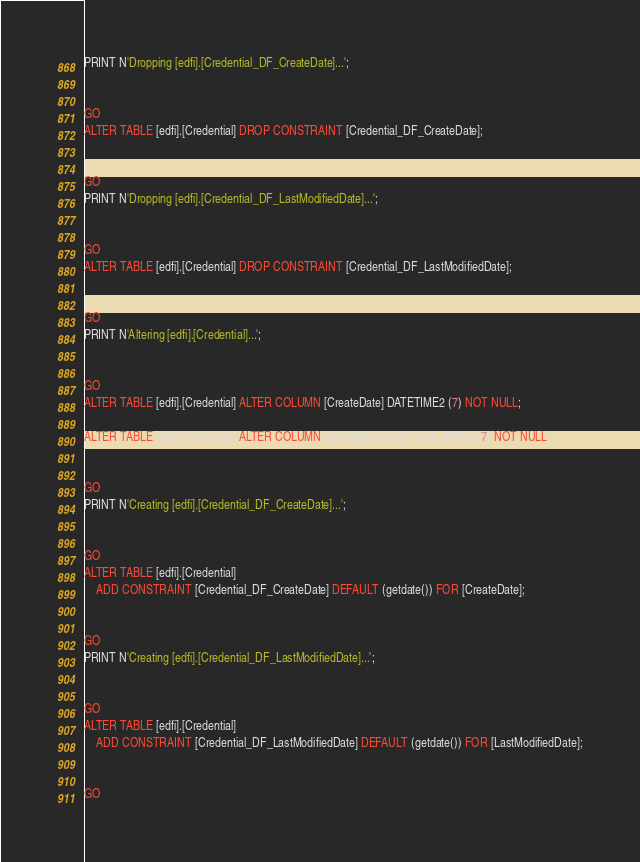<code> <loc_0><loc_0><loc_500><loc_500><_SQL_>
PRINT N'Dropping [edfi].[Credential_DF_CreateDate]...';


GO
ALTER TABLE [edfi].[Credential] DROP CONSTRAINT [Credential_DF_CreateDate];


GO
PRINT N'Dropping [edfi].[Credential_DF_LastModifiedDate]...';


GO
ALTER TABLE [edfi].[Credential] DROP CONSTRAINT [Credential_DF_LastModifiedDate];


GO
PRINT N'Altering [edfi].[Credential]...';


GO
ALTER TABLE [edfi].[Credential] ALTER COLUMN [CreateDate] DATETIME2 (7) NOT NULL;

ALTER TABLE [edfi].[Credential] ALTER COLUMN [LastModifiedDate] DATETIME2 (7) NOT NULL;


GO
PRINT N'Creating [edfi].[Credential_DF_CreateDate]...';


GO
ALTER TABLE [edfi].[Credential]
    ADD CONSTRAINT [Credential_DF_CreateDate] DEFAULT (getdate()) FOR [CreateDate];


GO
PRINT N'Creating [edfi].[Credential_DF_LastModifiedDate]...';


GO
ALTER TABLE [edfi].[Credential]
    ADD CONSTRAINT [Credential_DF_LastModifiedDate] DEFAULT (getdate()) FOR [LastModifiedDate];


GO
</code> 